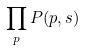<formula> <loc_0><loc_0><loc_500><loc_500>\prod _ { p } P ( p , s )</formula> 